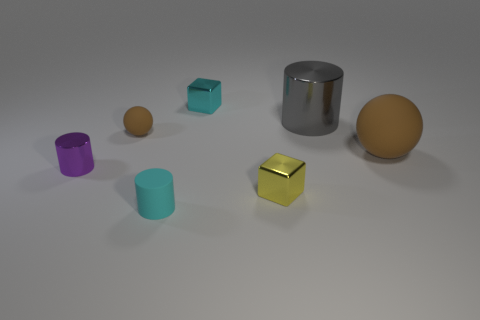Subtract all brown spheres. How many were subtracted if there are1brown spheres left? 1 Subtract all metal cylinders. How many cylinders are left? 1 Subtract all purple cylinders. How many cylinders are left? 2 Subtract 2 cylinders. How many cylinders are left? 1 Subtract all yellow blocks. Subtract all purple cylinders. How many blocks are left? 1 Subtract all yellow blocks. How many red balls are left? 0 Add 6 tiny cylinders. How many tiny cylinders are left? 8 Add 4 tiny cyan rubber objects. How many tiny cyan rubber objects exist? 5 Add 2 tiny purple metallic cylinders. How many objects exist? 9 Subtract 0 blue cylinders. How many objects are left? 7 